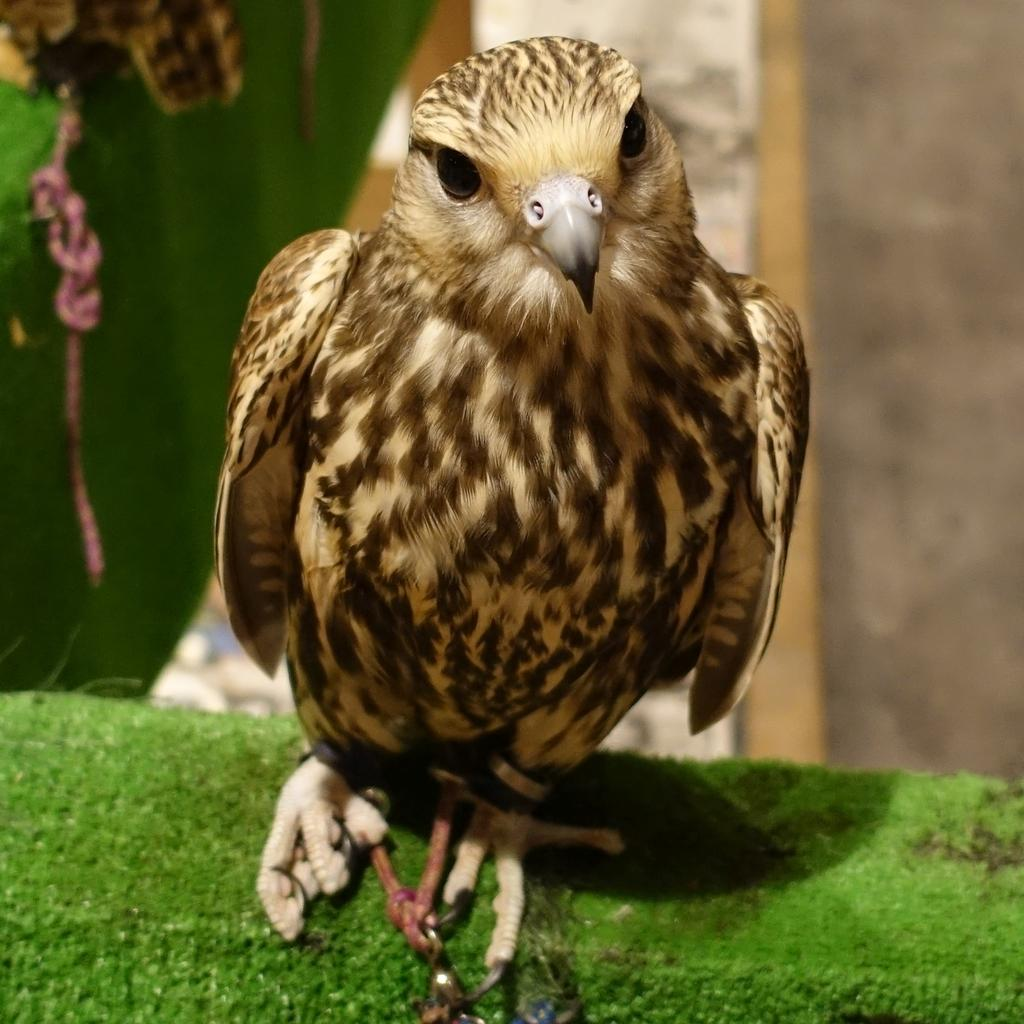What type of animal is in the image? There is a bird in the image. What colors can be seen on the bird? The bird has brown and cream colors. What is the bird standing on in the image? The bird is on a green surface. How would you describe the background of the image? The background of the image is blurred. How many cents are visible in the image? There are no cents present in the image. What type of cow can be seen in the image? There is no cow present in the image; it features a bird. What color are the crayons in the image? There are no crayons present in the image. 